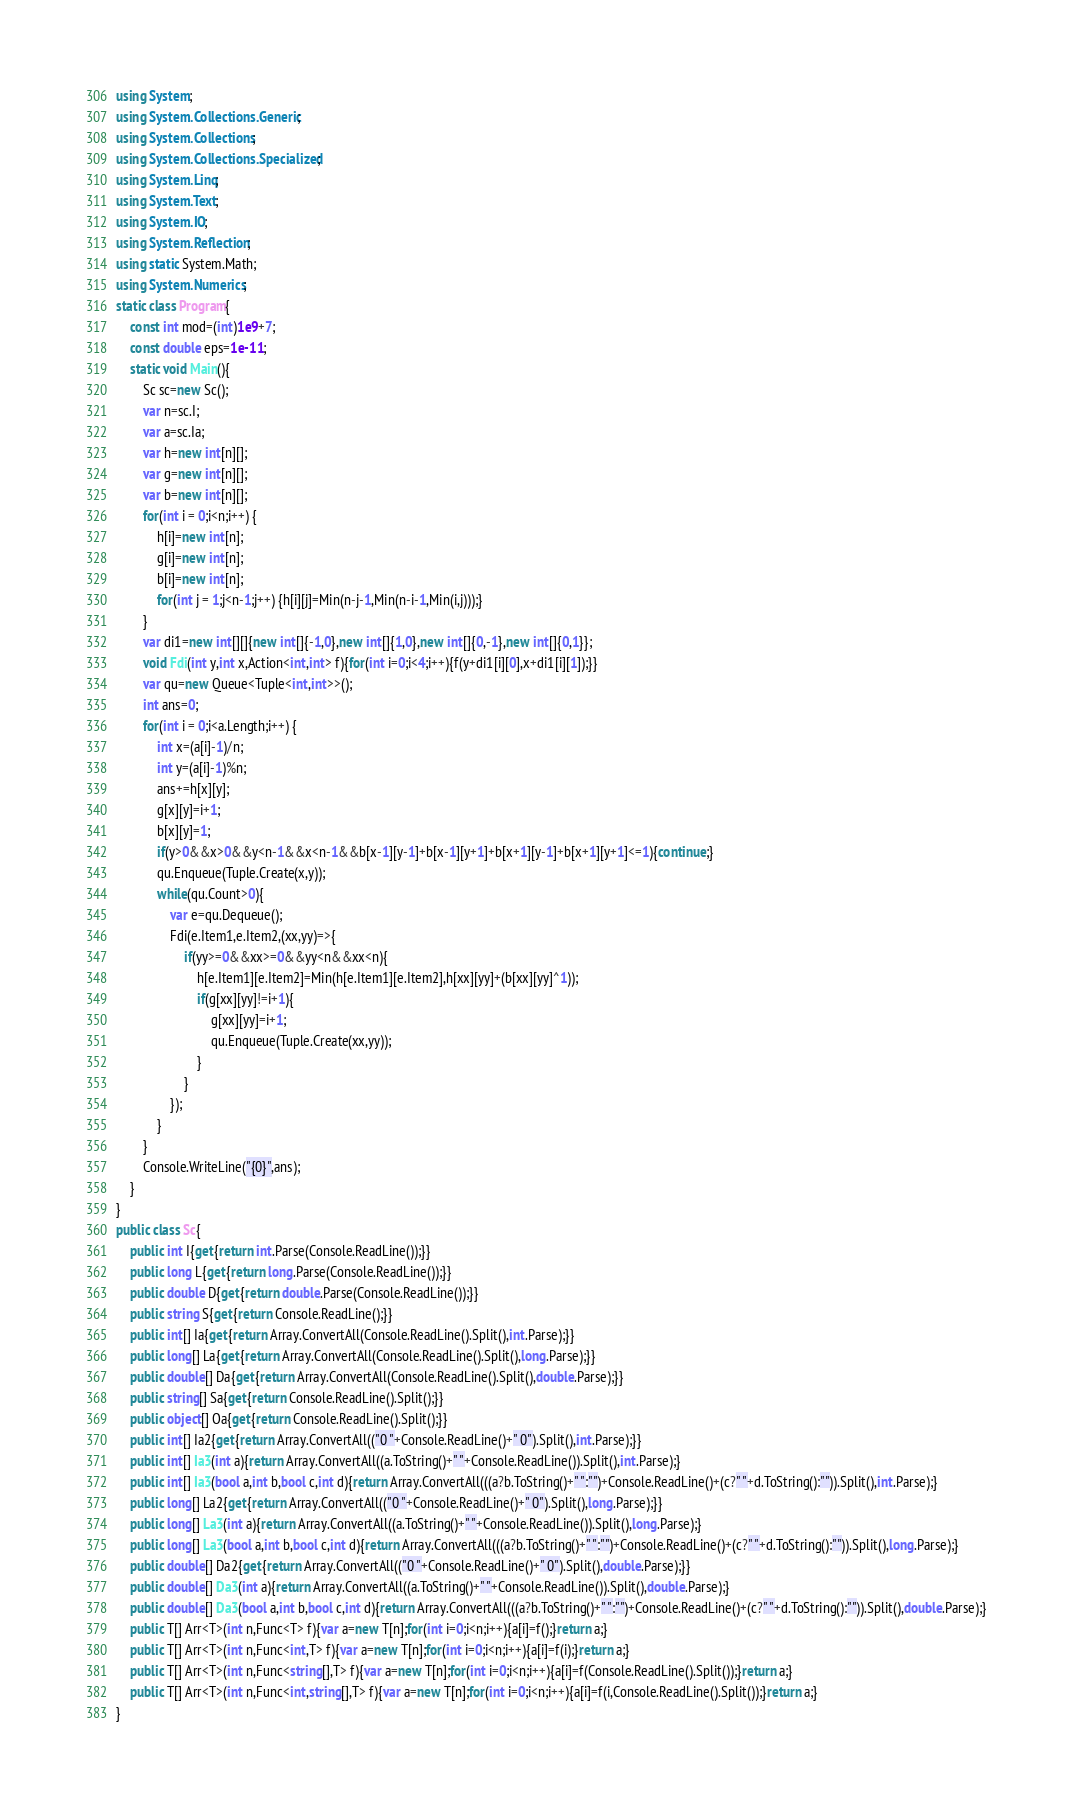<code> <loc_0><loc_0><loc_500><loc_500><_C#_>using System;
using System.Collections.Generic;
using System.Collections;
using System.Collections.Specialized;
using System.Linq;
using System.Text;
using System.IO;
using System.Reflection;
using static System.Math;
using System.Numerics;
static class Program{
	const int mod=(int)1e9+7;
	const double eps=1e-11;
	static void Main(){
		Sc sc=new Sc();
		var n=sc.I;
		var a=sc.Ia;
		var h=new int[n][];
		var g=new int[n][];
		var b=new int[n][];
		for(int i = 0;i<n;i++) {
			h[i]=new int[n];
			g[i]=new int[n];
			b[i]=new int[n];
			for(int j = 1;j<n-1;j++) {h[i][j]=Min(n-j-1,Min(n-i-1,Min(i,j)));}
		}
		var di1=new int[][]{new int[]{-1,0},new int[]{1,0},new int[]{0,-1},new int[]{0,1}};
		void Fdi(int y,int x,Action<int,int> f){for(int i=0;i<4;i++){f(y+di1[i][0],x+di1[i][1]);}}
		var qu=new Queue<Tuple<int,int>>();
		int ans=0;
		for(int i = 0;i<a.Length;i++) {
			int x=(a[i]-1)/n;
			int y=(a[i]-1)%n;
			ans+=h[x][y];
			g[x][y]=i+1;
			b[x][y]=1;
			if(y>0&&x>0&&y<n-1&&x<n-1&&b[x-1][y-1]+b[x-1][y+1]+b[x+1][y-1]+b[x+1][y+1]<=1){continue;}
			qu.Enqueue(Tuple.Create(x,y));
			while(qu.Count>0){
				var e=qu.Dequeue();
				Fdi(e.Item1,e.Item2,(xx,yy)=>{
					if(yy>=0&&xx>=0&&yy<n&&xx<n){
						h[e.Item1][e.Item2]=Min(h[e.Item1][e.Item2],h[xx][yy]+(b[xx][yy]^1));
						if(g[xx][yy]!=i+1){
							g[xx][yy]=i+1;
							qu.Enqueue(Tuple.Create(xx,yy));
						}
					}
				});
			}
		}
		Console.WriteLine("{0}",ans);
	}
}
public class Sc{
	public int I{get{return int.Parse(Console.ReadLine());}}
	public long L{get{return long.Parse(Console.ReadLine());}}
	public double D{get{return double.Parse(Console.ReadLine());}}
	public string S{get{return Console.ReadLine();}}
	public int[] Ia{get{return Array.ConvertAll(Console.ReadLine().Split(),int.Parse);}}
	public long[] La{get{return Array.ConvertAll(Console.ReadLine().Split(),long.Parse);}}
	public double[] Da{get{return Array.ConvertAll(Console.ReadLine().Split(),double.Parse);}}
	public string[] Sa{get{return Console.ReadLine().Split();}}
	public object[] Oa{get{return Console.ReadLine().Split();}}
	public int[] Ia2{get{return Array.ConvertAll(("0 "+Console.ReadLine()+" 0").Split(),int.Parse);}}
	public int[] Ia3(int a){return Array.ConvertAll((a.ToString()+" "+Console.ReadLine()).Split(),int.Parse);}
	public int[] Ia3(bool a,int b,bool c,int d){return Array.ConvertAll(((a?b.ToString()+" ":"")+Console.ReadLine()+(c?" "+d.ToString():"")).Split(),int.Parse);}
	public long[] La2{get{return Array.ConvertAll(("0 "+Console.ReadLine()+" 0").Split(),long.Parse);}}
	public long[] La3(int a){return Array.ConvertAll((a.ToString()+" "+Console.ReadLine()).Split(),long.Parse);}
	public long[] La3(bool a,int b,bool c,int d){return Array.ConvertAll(((a?b.ToString()+" ":"")+Console.ReadLine()+(c?" "+d.ToString():"")).Split(),long.Parse);}
	public double[] Da2{get{return Array.ConvertAll(("0 "+Console.ReadLine()+" 0").Split(),double.Parse);}}
	public double[] Da3(int a){return Array.ConvertAll((a.ToString()+" "+Console.ReadLine()).Split(),double.Parse);}
	public double[] Da3(bool a,int b,bool c,int d){return Array.ConvertAll(((a?b.ToString()+" ":"")+Console.ReadLine()+(c?" "+d.ToString():"")).Split(),double.Parse);}
	public T[] Arr<T>(int n,Func<T> f){var a=new T[n];for(int i=0;i<n;i++){a[i]=f();}return a;}
	public T[] Arr<T>(int n,Func<int,T> f){var a=new T[n];for(int i=0;i<n;i++){a[i]=f(i);}return a;}
	public T[] Arr<T>(int n,Func<string[],T> f){var a=new T[n];for(int i=0;i<n;i++){a[i]=f(Console.ReadLine().Split());}return a;}
	public T[] Arr<T>(int n,Func<int,string[],T> f){var a=new T[n];for(int i=0;i<n;i++){a[i]=f(i,Console.ReadLine().Split());}return a;}
}</code> 